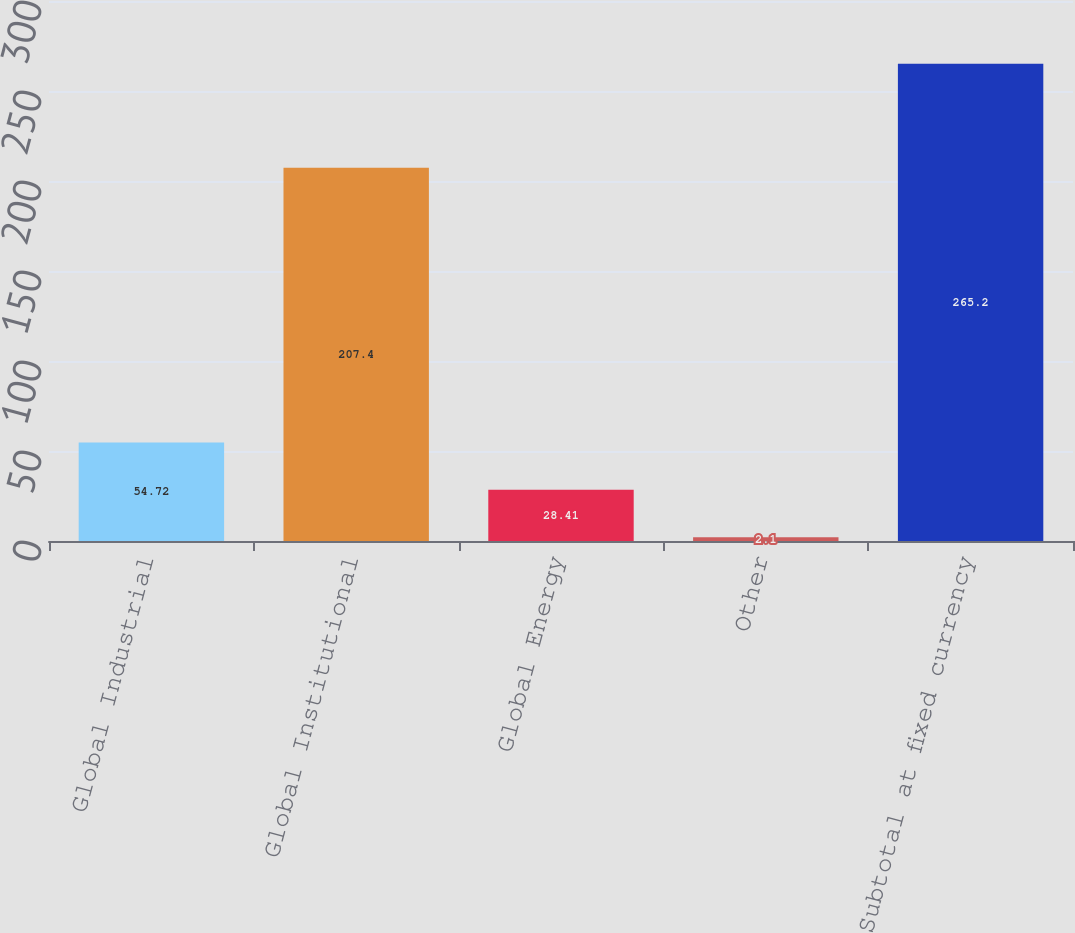Convert chart to OTSL. <chart><loc_0><loc_0><loc_500><loc_500><bar_chart><fcel>Global Industrial<fcel>Global Institutional<fcel>Global Energy<fcel>Other<fcel>Subtotal at fixed currency<nl><fcel>54.72<fcel>207.4<fcel>28.41<fcel>2.1<fcel>265.2<nl></chart> 